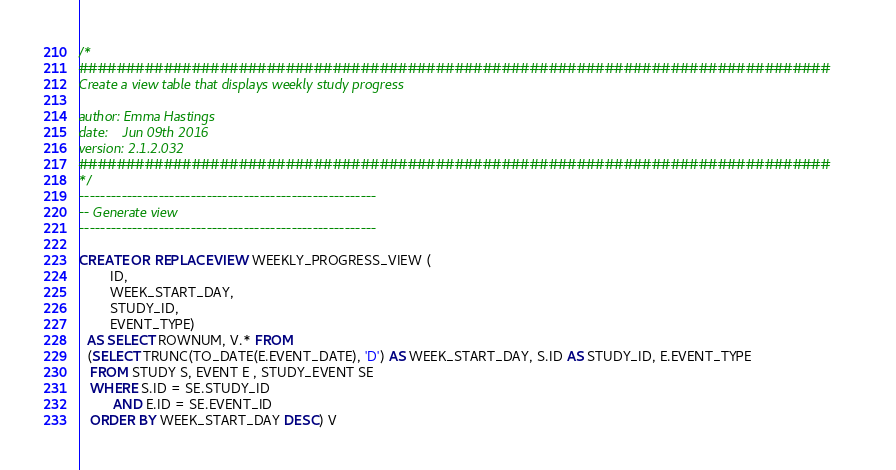<code> <loc_0><loc_0><loc_500><loc_500><_SQL_>/*
################################################################################
Create a view table that displays weekly study progress

author: Emma Hastings
date:    Jun 09th 2016
version: 2.1.2.032
################################################################################
*/
--------------------------------------------------------
-- Generate view
--------------------------------------------------------

CREATE OR REPLACE VIEW WEEKLY_PROGRESS_VIEW (
        ID,
        WEEK_START_DAY,
        STUDY_ID,
        EVENT_TYPE)
  AS SELECT ROWNUM, V.* FROM
  (SELECT TRUNC(TO_DATE(E.EVENT_DATE), 'D') AS WEEK_START_DAY, S.ID AS STUDY_ID, E.EVENT_TYPE
   FROM STUDY S, EVENT E , STUDY_EVENT SE
   WHERE S.ID = SE.STUDY_ID
         AND E.ID = SE.EVENT_ID
   ORDER BY WEEK_START_DAY DESC) V</code> 